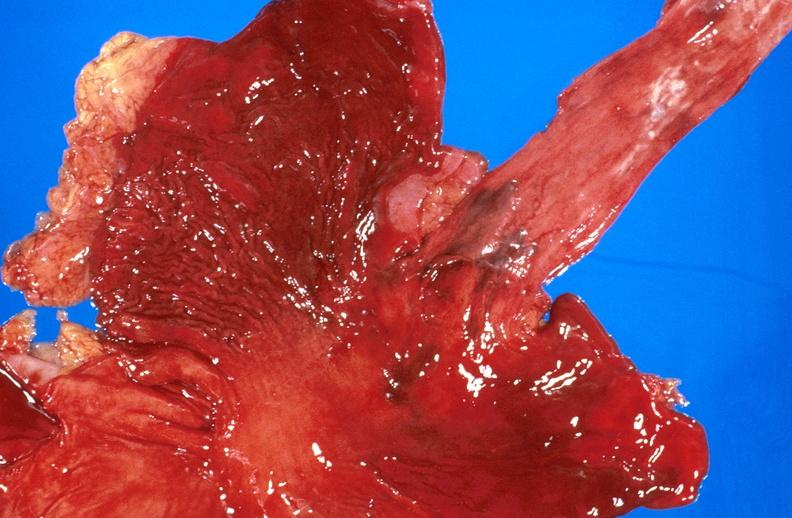what is present?
Answer the question using a single word or phrase. Gastrointestinal 